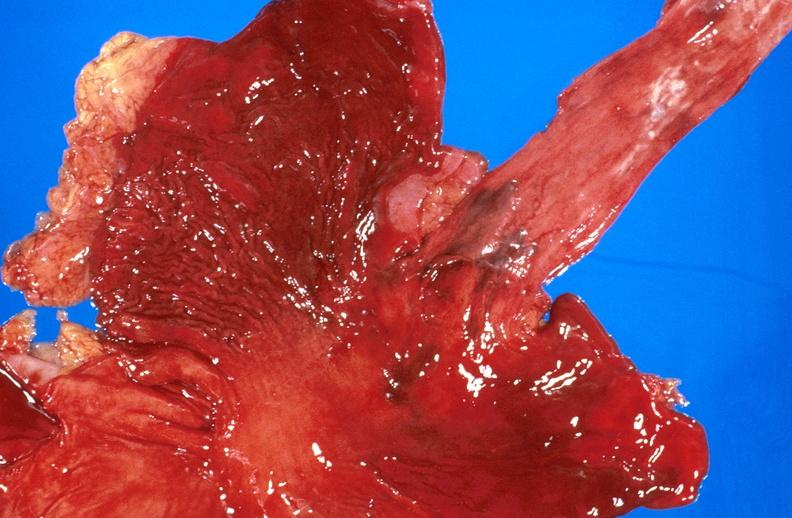what is present?
Answer the question using a single word or phrase. Gastrointestinal 